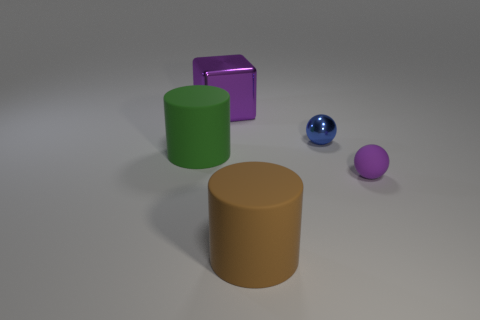Add 2 blue objects. How many objects exist? 7 Subtract all blocks. How many objects are left? 4 Subtract all tiny brown matte cubes. Subtract all purple metallic things. How many objects are left? 4 Add 3 cylinders. How many cylinders are left? 5 Add 1 tiny matte balls. How many tiny matte balls exist? 2 Subtract 0 red cubes. How many objects are left? 5 